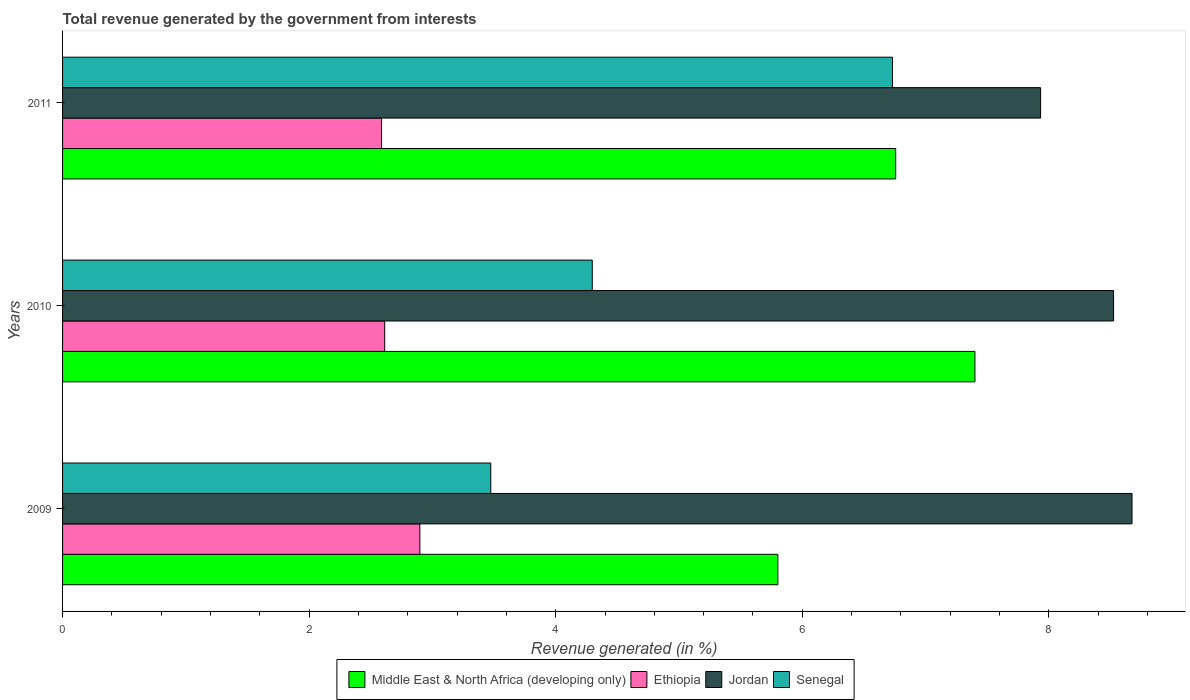How many different coloured bars are there?
Make the answer very short. 4. How many groups of bars are there?
Your response must be concise. 3. What is the label of the 3rd group of bars from the top?
Provide a succinct answer. 2009. In how many cases, is the number of bars for a given year not equal to the number of legend labels?
Give a very brief answer. 0. What is the total revenue generated in Ethiopia in 2011?
Provide a succinct answer. 2.59. Across all years, what is the maximum total revenue generated in Senegal?
Offer a terse response. 6.73. Across all years, what is the minimum total revenue generated in Middle East & North Africa (developing only)?
Make the answer very short. 5.8. In which year was the total revenue generated in Ethiopia maximum?
Your answer should be very brief. 2009. In which year was the total revenue generated in Senegal minimum?
Keep it short and to the point. 2009. What is the total total revenue generated in Middle East & North Africa (developing only) in the graph?
Provide a succinct answer. 19.96. What is the difference between the total revenue generated in Senegal in 2010 and that in 2011?
Offer a very short reply. -2.44. What is the difference between the total revenue generated in Senegal in 2010 and the total revenue generated in Middle East & North Africa (developing only) in 2009?
Offer a terse response. -1.51. What is the average total revenue generated in Jordan per year?
Your answer should be very brief. 8.38. In the year 2011, what is the difference between the total revenue generated in Jordan and total revenue generated in Ethiopia?
Your answer should be compact. 5.35. What is the ratio of the total revenue generated in Middle East & North Africa (developing only) in 2010 to that in 2011?
Ensure brevity in your answer.  1.1. What is the difference between the highest and the second highest total revenue generated in Middle East & North Africa (developing only)?
Your response must be concise. 0.64. What is the difference between the highest and the lowest total revenue generated in Jordan?
Your response must be concise. 0.74. Is the sum of the total revenue generated in Jordan in 2009 and 2010 greater than the maximum total revenue generated in Senegal across all years?
Make the answer very short. Yes. What does the 2nd bar from the top in 2011 represents?
Provide a short and direct response. Jordan. What does the 1st bar from the bottom in 2011 represents?
Provide a short and direct response. Middle East & North Africa (developing only). How many bars are there?
Your answer should be very brief. 12. Are all the bars in the graph horizontal?
Your answer should be very brief. Yes. What is the difference between two consecutive major ticks on the X-axis?
Offer a terse response. 2. Are the values on the major ticks of X-axis written in scientific E-notation?
Offer a terse response. No. Does the graph contain any zero values?
Provide a short and direct response. No. Does the graph contain grids?
Offer a very short reply. No. What is the title of the graph?
Keep it short and to the point. Total revenue generated by the government from interests. Does "Fragile and conflict affected situations" appear as one of the legend labels in the graph?
Offer a very short reply. No. What is the label or title of the X-axis?
Your response must be concise. Revenue generated (in %). What is the Revenue generated (in %) of Middle East & North Africa (developing only) in 2009?
Offer a very short reply. 5.8. What is the Revenue generated (in %) of Ethiopia in 2009?
Your answer should be compact. 2.9. What is the Revenue generated (in %) in Jordan in 2009?
Your answer should be very brief. 8.67. What is the Revenue generated (in %) of Senegal in 2009?
Provide a succinct answer. 3.47. What is the Revenue generated (in %) of Middle East & North Africa (developing only) in 2010?
Ensure brevity in your answer.  7.4. What is the Revenue generated (in %) of Ethiopia in 2010?
Your answer should be very brief. 2.61. What is the Revenue generated (in %) of Jordan in 2010?
Provide a short and direct response. 8.53. What is the Revenue generated (in %) of Senegal in 2010?
Ensure brevity in your answer.  4.3. What is the Revenue generated (in %) in Middle East & North Africa (developing only) in 2011?
Give a very brief answer. 6.76. What is the Revenue generated (in %) in Ethiopia in 2011?
Offer a terse response. 2.59. What is the Revenue generated (in %) of Jordan in 2011?
Your answer should be very brief. 7.93. What is the Revenue generated (in %) in Senegal in 2011?
Make the answer very short. 6.73. Across all years, what is the maximum Revenue generated (in %) of Middle East & North Africa (developing only)?
Offer a terse response. 7.4. Across all years, what is the maximum Revenue generated (in %) of Ethiopia?
Your answer should be compact. 2.9. Across all years, what is the maximum Revenue generated (in %) in Jordan?
Provide a short and direct response. 8.67. Across all years, what is the maximum Revenue generated (in %) of Senegal?
Ensure brevity in your answer.  6.73. Across all years, what is the minimum Revenue generated (in %) in Middle East & North Africa (developing only)?
Give a very brief answer. 5.8. Across all years, what is the minimum Revenue generated (in %) in Ethiopia?
Your response must be concise. 2.59. Across all years, what is the minimum Revenue generated (in %) in Jordan?
Give a very brief answer. 7.93. Across all years, what is the minimum Revenue generated (in %) in Senegal?
Keep it short and to the point. 3.47. What is the total Revenue generated (in %) in Middle East & North Africa (developing only) in the graph?
Provide a succinct answer. 19.96. What is the total Revenue generated (in %) in Ethiopia in the graph?
Your answer should be compact. 8.1. What is the total Revenue generated (in %) in Jordan in the graph?
Provide a succinct answer. 25.13. What is the total Revenue generated (in %) of Senegal in the graph?
Ensure brevity in your answer.  14.5. What is the difference between the Revenue generated (in %) in Middle East & North Africa (developing only) in 2009 and that in 2010?
Your answer should be compact. -1.6. What is the difference between the Revenue generated (in %) of Ethiopia in 2009 and that in 2010?
Give a very brief answer. 0.29. What is the difference between the Revenue generated (in %) in Jordan in 2009 and that in 2010?
Your response must be concise. 0.15. What is the difference between the Revenue generated (in %) of Senegal in 2009 and that in 2010?
Your answer should be compact. -0.82. What is the difference between the Revenue generated (in %) in Middle East & North Africa (developing only) in 2009 and that in 2011?
Ensure brevity in your answer.  -0.96. What is the difference between the Revenue generated (in %) in Ethiopia in 2009 and that in 2011?
Give a very brief answer. 0.31. What is the difference between the Revenue generated (in %) of Jordan in 2009 and that in 2011?
Your answer should be very brief. 0.74. What is the difference between the Revenue generated (in %) in Senegal in 2009 and that in 2011?
Make the answer very short. -3.26. What is the difference between the Revenue generated (in %) of Middle East & North Africa (developing only) in 2010 and that in 2011?
Ensure brevity in your answer.  0.64. What is the difference between the Revenue generated (in %) in Ethiopia in 2010 and that in 2011?
Your response must be concise. 0.03. What is the difference between the Revenue generated (in %) in Jordan in 2010 and that in 2011?
Make the answer very short. 0.59. What is the difference between the Revenue generated (in %) in Senegal in 2010 and that in 2011?
Keep it short and to the point. -2.44. What is the difference between the Revenue generated (in %) of Middle East & North Africa (developing only) in 2009 and the Revenue generated (in %) of Ethiopia in 2010?
Make the answer very short. 3.19. What is the difference between the Revenue generated (in %) in Middle East & North Africa (developing only) in 2009 and the Revenue generated (in %) in Jordan in 2010?
Offer a terse response. -2.72. What is the difference between the Revenue generated (in %) in Middle East & North Africa (developing only) in 2009 and the Revenue generated (in %) in Senegal in 2010?
Your response must be concise. 1.51. What is the difference between the Revenue generated (in %) in Ethiopia in 2009 and the Revenue generated (in %) in Jordan in 2010?
Keep it short and to the point. -5.63. What is the difference between the Revenue generated (in %) of Ethiopia in 2009 and the Revenue generated (in %) of Senegal in 2010?
Provide a succinct answer. -1.4. What is the difference between the Revenue generated (in %) in Jordan in 2009 and the Revenue generated (in %) in Senegal in 2010?
Give a very brief answer. 4.38. What is the difference between the Revenue generated (in %) in Middle East & North Africa (developing only) in 2009 and the Revenue generated (in %) in Ethiopia in 2011?
Provide a short and direct response. 3.21. What is the difference between the Revenue generated (in %) in Middle East & North Africa (developing only) in 2009 and the Revenue generated (in %) in Jordan in 2011?
Offer a terse response. -2.13. What is the difference between the Revenue generated (in %) in Middle East & North Africa (developing only) in 2009 and the Revenue generated (in %) in Senegal in 2011?
Offer a terse response. -0.93. What is the difference between the Revenue generated (in %) of Ethiopia in 2009 and the Revenue generated (in %) of Jordan in 2011?
Your answer should be compact. -5.04. What is the difference between the Revenue generated (in %) of Ethiopia in 2009 and the Revenue generated (in %) of Senegal in 2011?
Provide a short and direct response. -3.83. What is the difference between the Revenue generated (in %) in Jordan in 2009 and the Revenue generated (in %) in Senegal in 2011?
Your response must be concise. 1.94. What is the difference between the Revenue generated (in %) of Middle East & North Africa (developing only) in 2010 and the Revenue generated (in %) of Ethiopia in 2011?
Provide a short and direct response. 4.81. What is the difference between the Revenue generated (in %) in Middle East & North Africa (developing only) in 2010 and the Revenue generated (in %) in Jordan in 2011?
Provide a succinct answer. -0.53. What is the difference between the Revenue generated (in %) of Middle East & North Africa (developing only) in 2010 and the Revenue generated (in %) of Senegal in 2011?
Offer a very short reply. 0.67. What is the difference between the Revenue generated (in %) of Ethiopia in 2010 and the Revenue generated (in %) of Jordan in 2011?
Provide a short and direct response. -5.32. What is the difference between the Revenue generated (in %) in Ethiopia in 2010 and the Revenue generated (in %) in Senegal in 2011?
Make the answer very short. -4.12. What is the difference between the Revenue generated (in %) in Jordan in 2010 and the Revenue generated (in %) in Senegal in 2011?
Give a very brief answer. 1.79. What is the average Revenue generated (in %) in Middle East & North Africa (developing only) per year?
Offer a terse response. 6.65. What is the average Revenue generated (in %) in Ethiopia per year?
Your answer should be very brief. 2.7. What is the average Revenue generated (in %) in Jordan per year?
Keep it short and to the point. 8.38. What is the average Revenue generated (in %) of Senegal per year?
Give a very brief answer. 4.83. In the year 2009, what is the difference between the Revenue generated (in %) in Middle East & North Africa (developing only) and Revenue generated (in %) in Ethiopia?
Make the answer very short. 2.9. In the year 2009, what is the difference between the Revenue generated (in %) of Middle East & North Africa (developing only) and Revenue generated (in %) of Jordan?
Your answer should be compact. -2.87. In the year 2009, what is the difference between the Revenue generated (in %) of Middle East & North Africa (developing only) and Revenue generated (in %) of Senegal?
Provide a short and direct response. 2.33. In the year 2009, what is the difference between the Revenue generated (in %) in Ethiopia and Revenue generated (in %) in Jordan?
Give a very brief answer. -5.78. In the year 2009, what is the difference between the Revenue generated (in %) of Ethiopia and Revenue generated (in %) of Senegal?
Your response must be concise. -0.58. In the year 2009, what is the difference between the Revenue generated (in %) of Jordan and Revenue generated (in %) of Senegal?
Your answer should be very brief. 5.2. In the year 2010, what is the difference between the Revenue generated (in %) in Middle East & North Africa (developing only) and Revenue generated (in %) in Ethiopia?
Your response must be concise. 4.79. In the year 2010, what is the difference between the Revenue generated (in %) of Middle East & North Africa (developing only) and Revenue generated (in %) of Jordan?
Provide a short and direct response. -1.12. In the year 2010, what is the difference between the Revenue generated (in %) of Middle East & North Africa (developing only) and Revenue generated (in %) of Senegal?
Make the answer very short. 3.1. In the year 2010, what is the difference between the Revenue generated (in %) of Ethiopia and Revenue generated (in %) of Jordan?
Offer a very short reply. -5.91. In the year 2010, what is the difference between the Revenue generated (in %) of Ethiopia and Revenue generated (in %) of Senegal?
Provide a short and direct response. -1.68. In the year 2010, what is the difference between the Revenue generated (in %) of Jordan and Revenue generated (in %) of Senegal?
Offer a very short reply. 4.23. In the year 2011, what is the difference between the Revenue generated (in %) of Middle East & North Africa (developing only) and Revenue generated (in %) of Ethiopia?
Give a very brief answer. 4.17. In the year 2011, what is the difference between the Revenue generated (in %) of Middle East & North Africa (developing only) and Revenue generated (in %) of Jordan?
Your answer should be very brief. -1.18. In the year 2011, what is the difference between the Revenue generated (in %) of Middle East & North Africa (developing only) and Revenue generated (in %) of Senegal?
Keep it short and to the point. 0.03. In the year 2011, what is the difference between the Revenue generated (in %) in Ethiopia and Revenue generated (in %) in Jordan?
Offer a very short reply. -5.35. In the year 2011, what is the difference between the Revenue generated (in %) in Ethiopia and Revenue generated (in %) in Senegal?
Provide a short and direct response. -4.14. In the year 2011, what is the difference between the Revenue generated (in %) of Jordan and Revenue generated (in %) of Senegal?
Provide a short and direct response. 1.2. What is the ratio of the Revenue generated (in %) of Middle East & North Africa (developing only) in 2009 to that in 2010?
Provide a succinct answer. 0.78. What is the ratio of the Revenue generated (in %) in Ethiopia in 2009 to that in 2010?
Give a very brief answer. 1.11. What is the ratio of the Revenue generated (in %) of Jordan in 2009 to that in 2010?
Make the answer very short. 1.02. What is the ratio of the Revenue generated (in %) of Senegal in 2009 to that in 2010?
Make the answer very short. 0.81. What is the ratio of the Revenue generated (in %) in Middle East & North Africa (developing only) in 2009 to that in 2011?
Provide a succinct answer. 0.86. What is the ratio of the Revenue generated (in %) of Ethiopia in 2009 to that in 2011?
Give a very brief answer. 1.12. What is the ratio of the Revenue generated (in %) in Jordan in 2009 to that in 2011?
Make the answer very short. 1.09. What is the ratio of the Revenue generated (in %) of Senegal in 2009 to that in 2011?
Your answer should be very brief. 0.52. What is the ratio of the Revenue generated (in %) in Middle East & North Africa (developing only) in 2010 to that in 2011?
Keep it short and to the point. 1.1. What is the ratio of the Revenue generated (in %) of Ethiopia in 2010 to that in 2011?
Offer a terse response. 1.01. What is the ratio of the Revenue generated (in %) of Jordan in 2010 to that in 2011?
Ensure brevity in your answer.  1.07. What is the ratio of the Revenue generated (in %) of Senegal in 2010 to that in 2011?
Offer a very short reply. 0.64. What is the difference between the highest and the second highest Revenue generated (in %) in Middle East & North Africa (developing only)?
Offer a very short reply. 0.64. What is the difference between the highest and the second highest Revenue generated (in %) of Ethiopia?
Your answer should be very brief. 0.29. What is the difference between the highest and the second highest Revenue generated (in %) of Jordan?
Your response must be concise. 0.15. What is the difference between the highest and the second highest Revenue generated (in %) of Senegal?
Your answer should be compact. 2.44. What is the difference between the highest and the lowest Revenue generated (in %) in Middle East & North Africa (developing only)?
Your answer should be very brief. 1.6. What is the difference between the highest and the lowest Revenue generated (in %) of Ethiopia?
Make the answer very short. 0.31. What is the difference between the highest and the lowest Revenue generated (in %) in Jordan?
Offer a very short reply. 0.74. What is the difference between the highest and the lowest Revenue generated (in %) of Senegal?
Your answer should be compact. 3.26. 